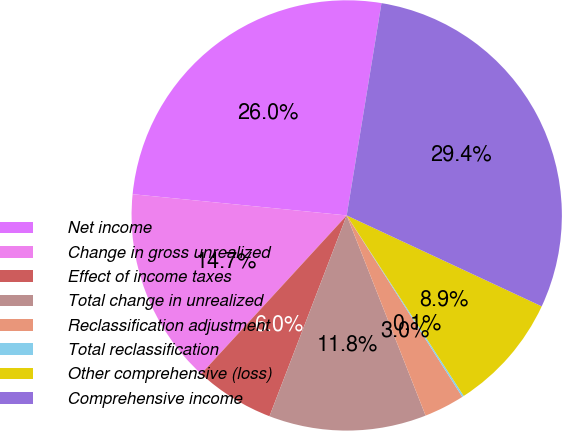<chart> <loc_0><loc_0><loc_500><loc_500><pie_chart><fcel>Net income<fcel>Change in gross unrealized<fcel>Effect of income taxes<fcel>Total change in unrealized<fcel>Reclassification adjustment<fcel>Total reclassification<fcel>Other comprehensive (loss)<fcel>Comprehensive income<nl><fcel>26.01%<fcel>14.75%<fcel>5.98%<fcel>11.82%<fcel>3.05%<fcel>0.13%<fcel>8.9%<fcel>29.36%<nl></chart> 